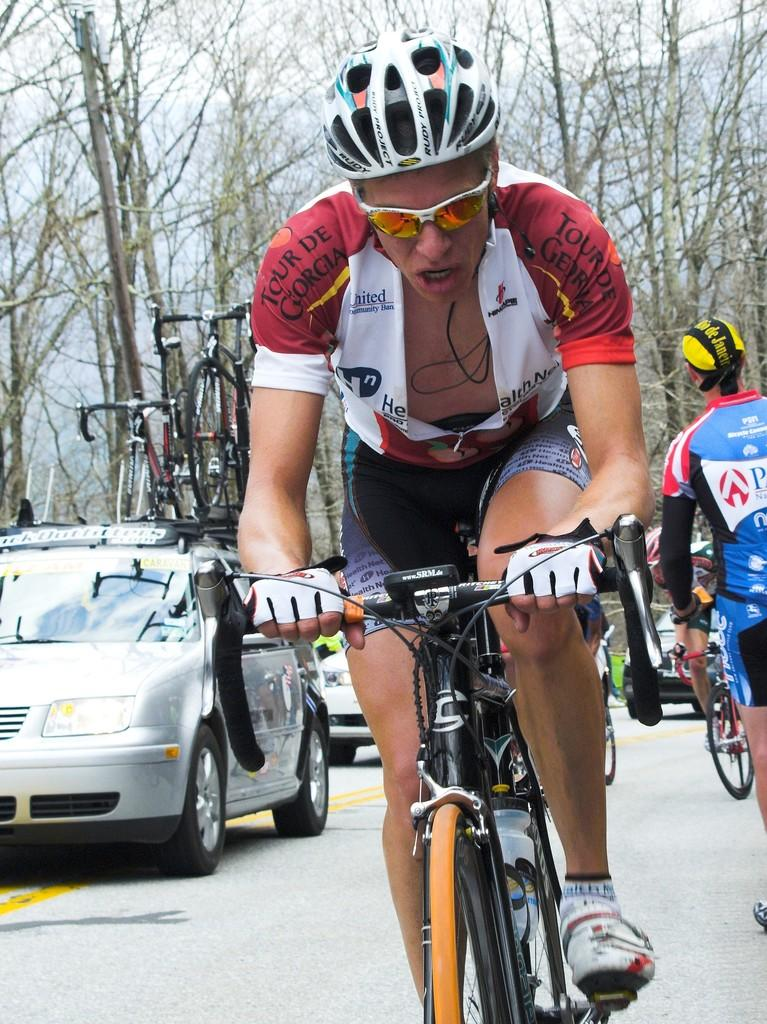What are the people in the image doing? The people in the image are cycling on a road. What else can be seen on the road in the image? There are vehicles in the image. What can be seen in the distance in the image? There are trees in the background of the image. What type of rod is being used by the cyclists to catch fish in the image? There is no rod or fishing activity present in the image; the people are cycling on a road. 